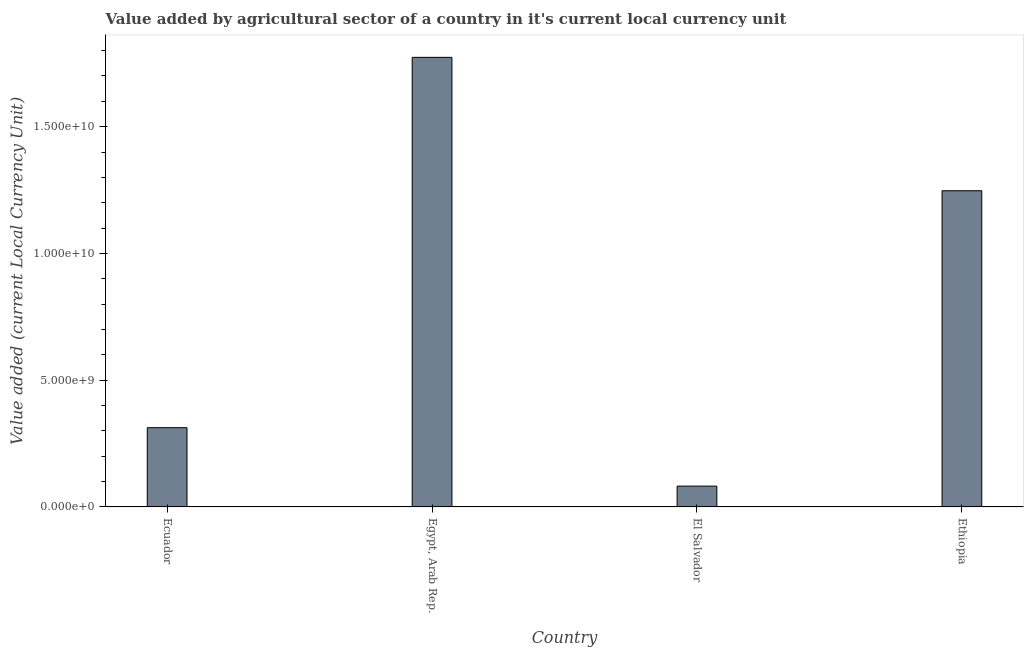What is the title of the graph?
Your response must be concise. Value added by agricultural sector of a country in it's current local currency unit. What is the label or title of the X-axis?
Provide a succinct answer. Country. What is the label or title of the Y-axis?
Ensure brevity in your answer.  Value added (current Local Currency Unit). What is the value added by agriculture sector in Ethiopia?
Your answer should be compact. 1.25e+1. Across all countries, what is the maximum value added by agriculture sector?
Give a very brief answer. 1.77e+1. Across all countries, what is the minimum value added by agriculture sector?
Give a very brief answer. 8.21e+08. In which country was the value added by agriculture sector maximum?
Your answer should be compact. Egypt, Arab Rep. In which country was the value added by agriculture sector minimum?
Offer a terse response. El Salvador. What is the sum of the value added by agriculture sector?
Your answer should be compact. 3.42e+1. What is the difference between the value added by agriculture sector in El Salvador and Ethiopia?
Your answer should be very brief. -1.17e+1. What is the average value added by agriculture sector per country?
Your response must be concise. 8.54e+09. What is the median value added by agriculture sector?
Your answer should be very brief. 7.80e+09. In how many countries, is the value added by agriculture sector greater than 7000000000 LCU?
Your response must be concise. 2. What is the ratio of the value added by agriculture sector in El Salvador to that in Ethiopia?
Ensure brevity in your answer.  0.07. Is the difference between the value added by agriculture sector in Ecuador and El Salvador greater than the difference between any two countries?
Your answer should be compact. No. What is the difference between the highest and the second highest value added by agriculture sector?
Give a very brief answer. 5.26e+09. What is the difference between the highest and the lowest value added by agriculture sector?
Give a very brief answer. 1.69e+1. In how many countries, is the value added by agriculture sector greater than the average value added by agriculture sector taken over all countries?
Make the answer very short. 2. How many bars are there?
Give a very brief answer. 4. Are all the bars in the graph horizontal?
Your response must be concise. No. How many countries are there in the graph?
Make the answer very short. 4. What is the Value added (current Local Currency Unit) in Ecuador?
Offer a very short reply. 3.13e+09. What is the Value added (current Local Currency Unit) of Egypt, Arab Rep.?
Keep it short and to the point. 1.77e+1. What is the Value added (current Local Currency Unit) in El Salvador?
Your answer should be very brief. 8.21e+08. What is the Value added (current Local Currency Unit) in Ethiopia?
Keep it short and to the point. 1.25e+1. What is the difference between the Value added (current Local Currency Unit) in Ecuador and Egypt, Arab Rep.?
Ensure brevity in your answer.  -1.46e+1. What is the difference between the Value added (current Local Currency Unit) in Ecuador and El Salvador?
Make the answer very short. 2.30e+09. What is the difference between the Value added (current Local Currency Unit) in Ecuador and Ethiopia?
Your answer should be very brief. -9.35e+09. What is the difference between the Value added (current Local Currency Unit) in Egypt, Arab Rep. and El Salvador?
Your answer should be compact. 1.69e+1. What is the difference between the Value added (current Local Currency Unit) in Egypt, Arab Rep. and Ethiopia?
Make the answer very short. 5.26e+09. What is the difference between the Value added (current Local Currency Unit) in El Salvador and Ethiopia?
Keep it short and to the point. -1.17e+1. What is the ratio of the Value added (current Local Currency Unit) in Ecuador to that in Egypt, Arab Rep.?
Your response must be concise. 0.18. What is the ratio of the Value added (current Local Currency Unit) in Ecuador to that in El Salvador?
Keep it short and to the point. 3.81. What is the ratio of the Value added (current Local Currency Unit) in Ecuador to that in Ethiopia?
Keep it short and to the point. 0.25. What is the ratio of the Value added (current Local Currency Unit) in Egypt, Arab Rep. to that in El Salvador?
Your answer should be very brief. 21.6. What is the ratio of the Value added (current Local Currency Unit) in Egypt, Arab Rep. to that in Ethiopia?
Give a very brief answer. 1.42. What is the ratio of the Value added (current Local Currency Unit) in El Salvador to that in Ethiopia?
Offer a terse response. 0.07. 